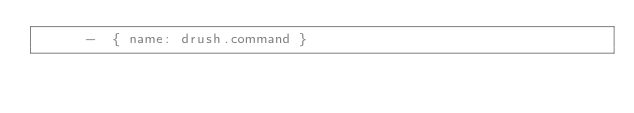Convert code to text. <code><loc_0><loc_0><loc_500><loc_500><_YAML_>      -  { name: drush.command }
</code> 